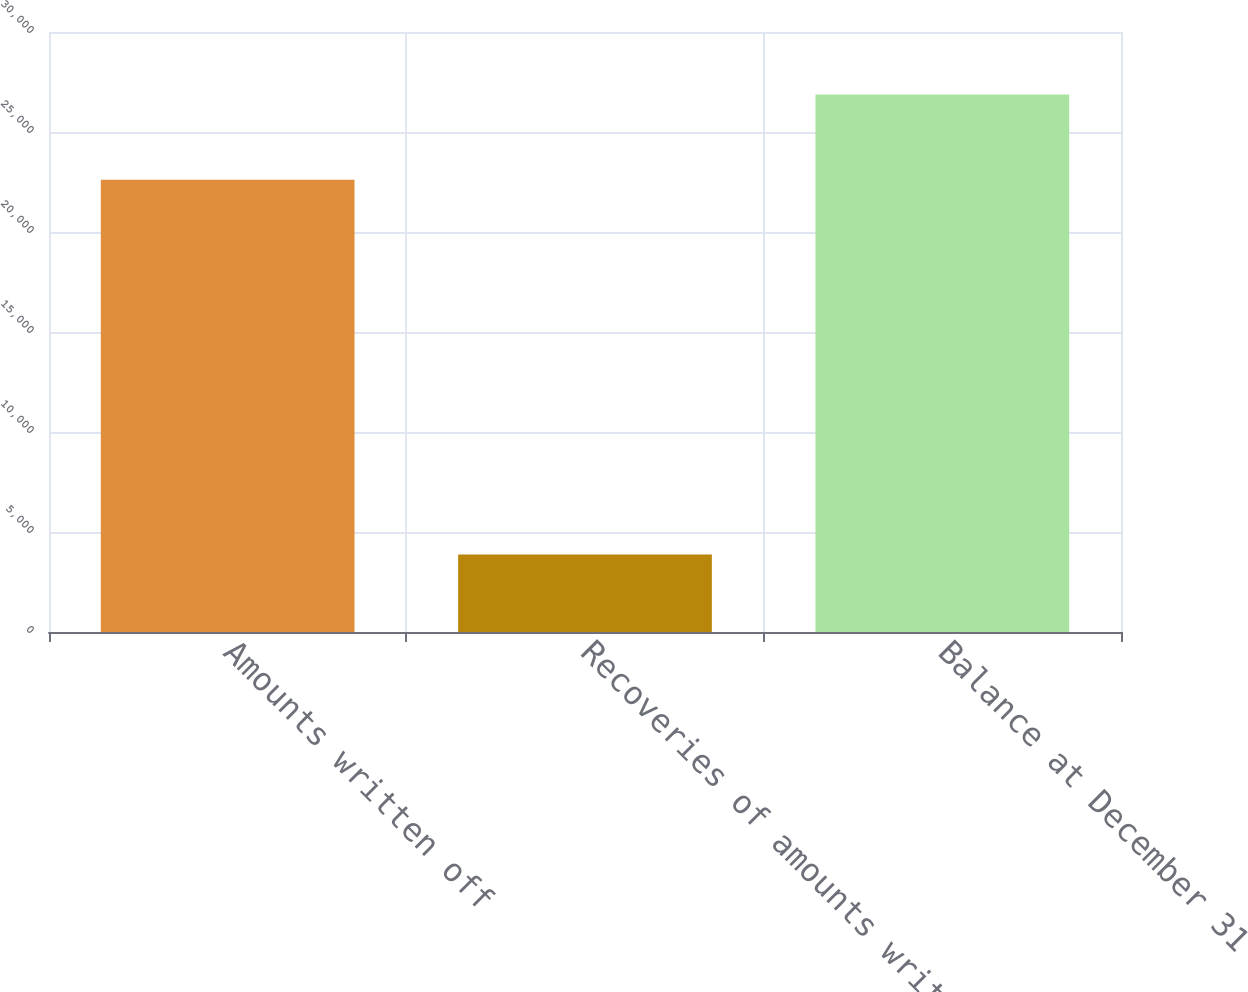Convert chart. <chart><loc_0><loc_0><loc_500><loc_500><bar_chart><fcel>Amounts written off<fcel>Recoveries of amounts written<fcel>Balance at December 31<nl><fcel>22607<fcel>3875<fcel>26874<nl></chart> 